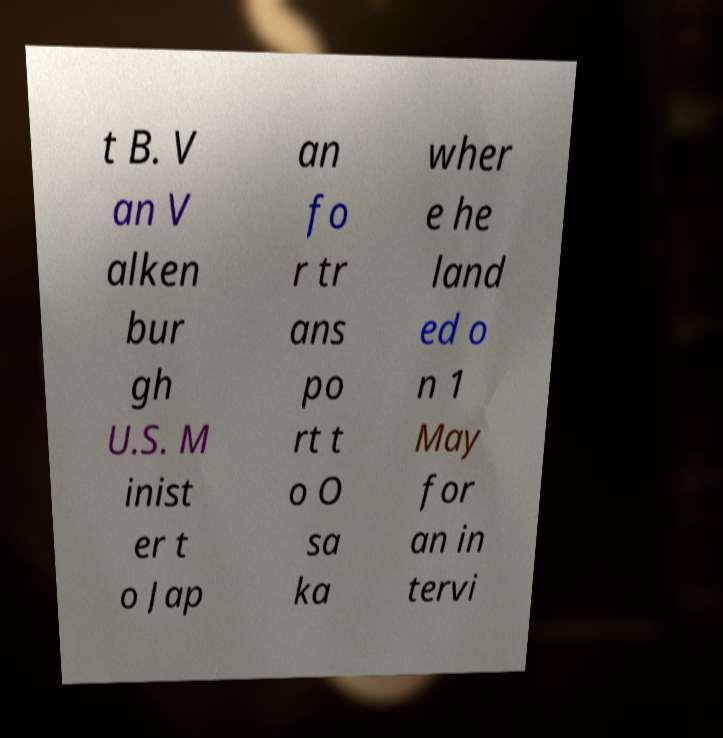Please read and relay the text visible in this image. What does it say? t B. V an V alken bur gh U.S. M inist er t o Jap an fo r tr ans po rt t o O sa ka wher e he land ed o n 1 May for an in tervi 